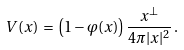<formula> <loc_0><loc_0><loc_500><loc_500>V ( x ) \, = \, \left ( 1 - \varphi ( x ) \right ) \frac { x ^ { \bot } } { 4 \pi | x | ^ { 2 } } \, .</formula> 